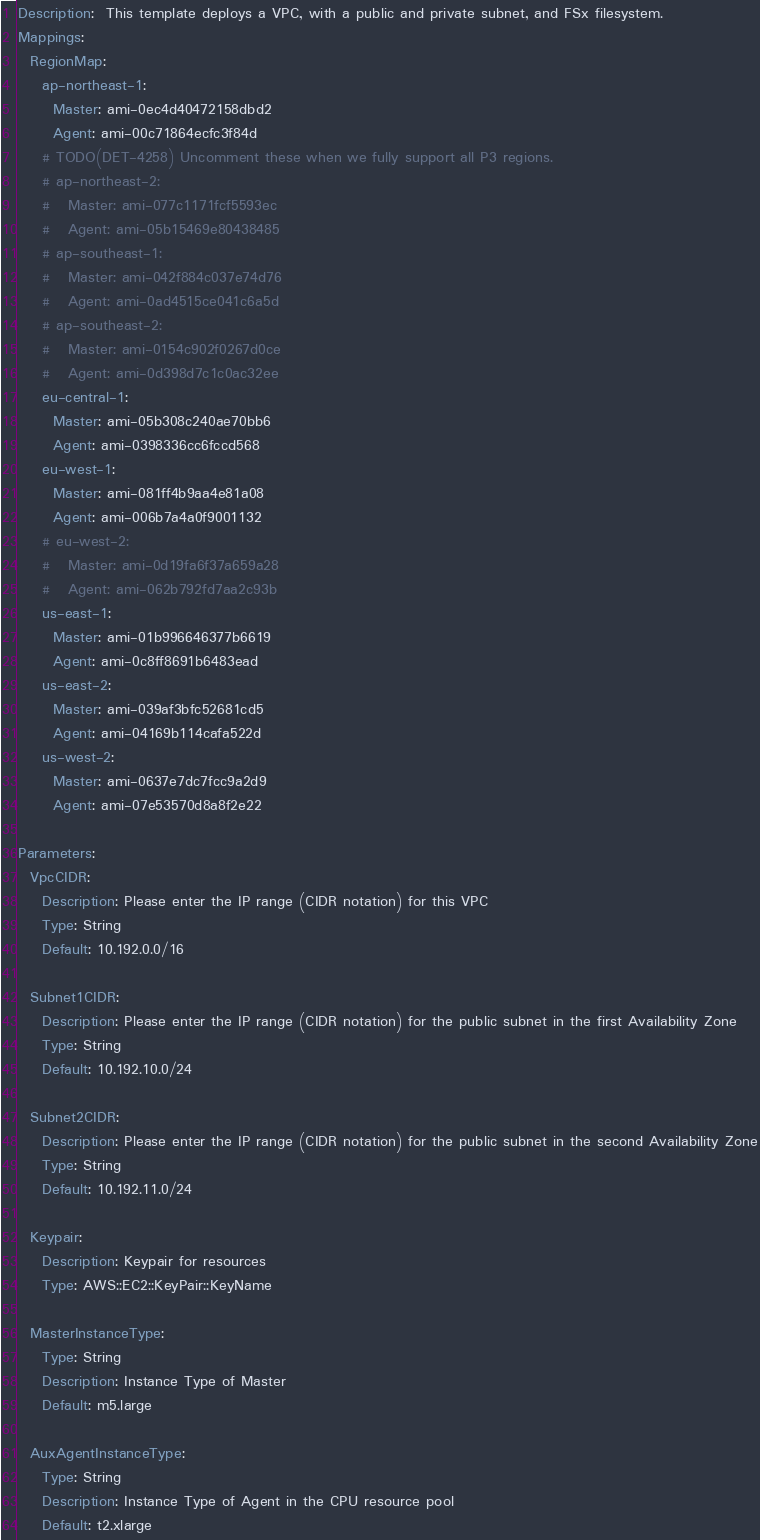<code> <loc_0><loc_0><loc_500><loc_500><_YAML_>Description:  This template deploys a VPC, with a public and private subnet, and FSx filesystem.
Mappings:
  RegionMap:
    ap-northeast-1:
      Master: ami-0ec4d40472158dbd2
      Agent: ami-00c71864ecfc3f84d
    # TODO(DET-4258) Uncomment these when we fully support all P3 regions.
    # ap-northeast-2:
    #   Master: ami-077c1171fcf5593ec
    #   Agent: ami-05b15469e80438485
    # ap-southeast-1:
    #   Master: ami-042f884c037e74d76
    #   Agent: ami-0ad4515ce041c6a5d
    # ap-southeast-2:
    #   Master: ami-0154c902f0267d0ce
    #   Agent: ami-0d398d7c1c0ac32ee
    eu-central-1:
      Master: ami-05b308c240ae70bb6
      Agent: ami-0398336cc6fccd568
    eu-west-1:
      Master: ami-081ff4b9aa4e81a08
      Agent: ami-006b7a4a0f9001132
    # eu-west-2:
    #   Master: ami-0d19fa6f37a659a28
    #   Agent: ami-062b792fd7aa2c93b
    us-east-1:
      Master: ami-01b996646377b6619
      Agent: ami-0c8ff8691b6483ead
    us-east-2:
      Master: ami-039af3bfc52681cd5
      Agent: ami-04169b114cafa522d
    us-west-2:
      Master: ami-0637e7dc7fcc9a2d9
      Agent: ami-07e53570d8a8f2e22

Parameters:
  VpcCIDR:
    Description: Please enter the IP range (CIDR notation) for this VPC
    Type: String
    Default: 10.192.0.0/16

  Subnet1CIDR:
    Description: Please enter the IP range (CIDR notation) for the public subnet in the first Availability Zone
    Type: String
    Default: 10.192.10.0/24

  Subnet2CIDR:
    Description: Please enter the IP range (CIDR notation) for the public subnet in the second Availability Zone
    Type: String
    Default: 10.192.11.0/24

  Keypair:
    Description: Keypair for resources
    Type: AWS::EC2::KeyPair::KeyName

  MasterInstanceType:
    Type: String
    Description: Instance Type of Master
    Default: m5.large

  AuxAgentInstanceType:
    Type: String
    Description: Instance Type of Agent in the CPU resource pool
    Default: t2.xlarge
</code> 